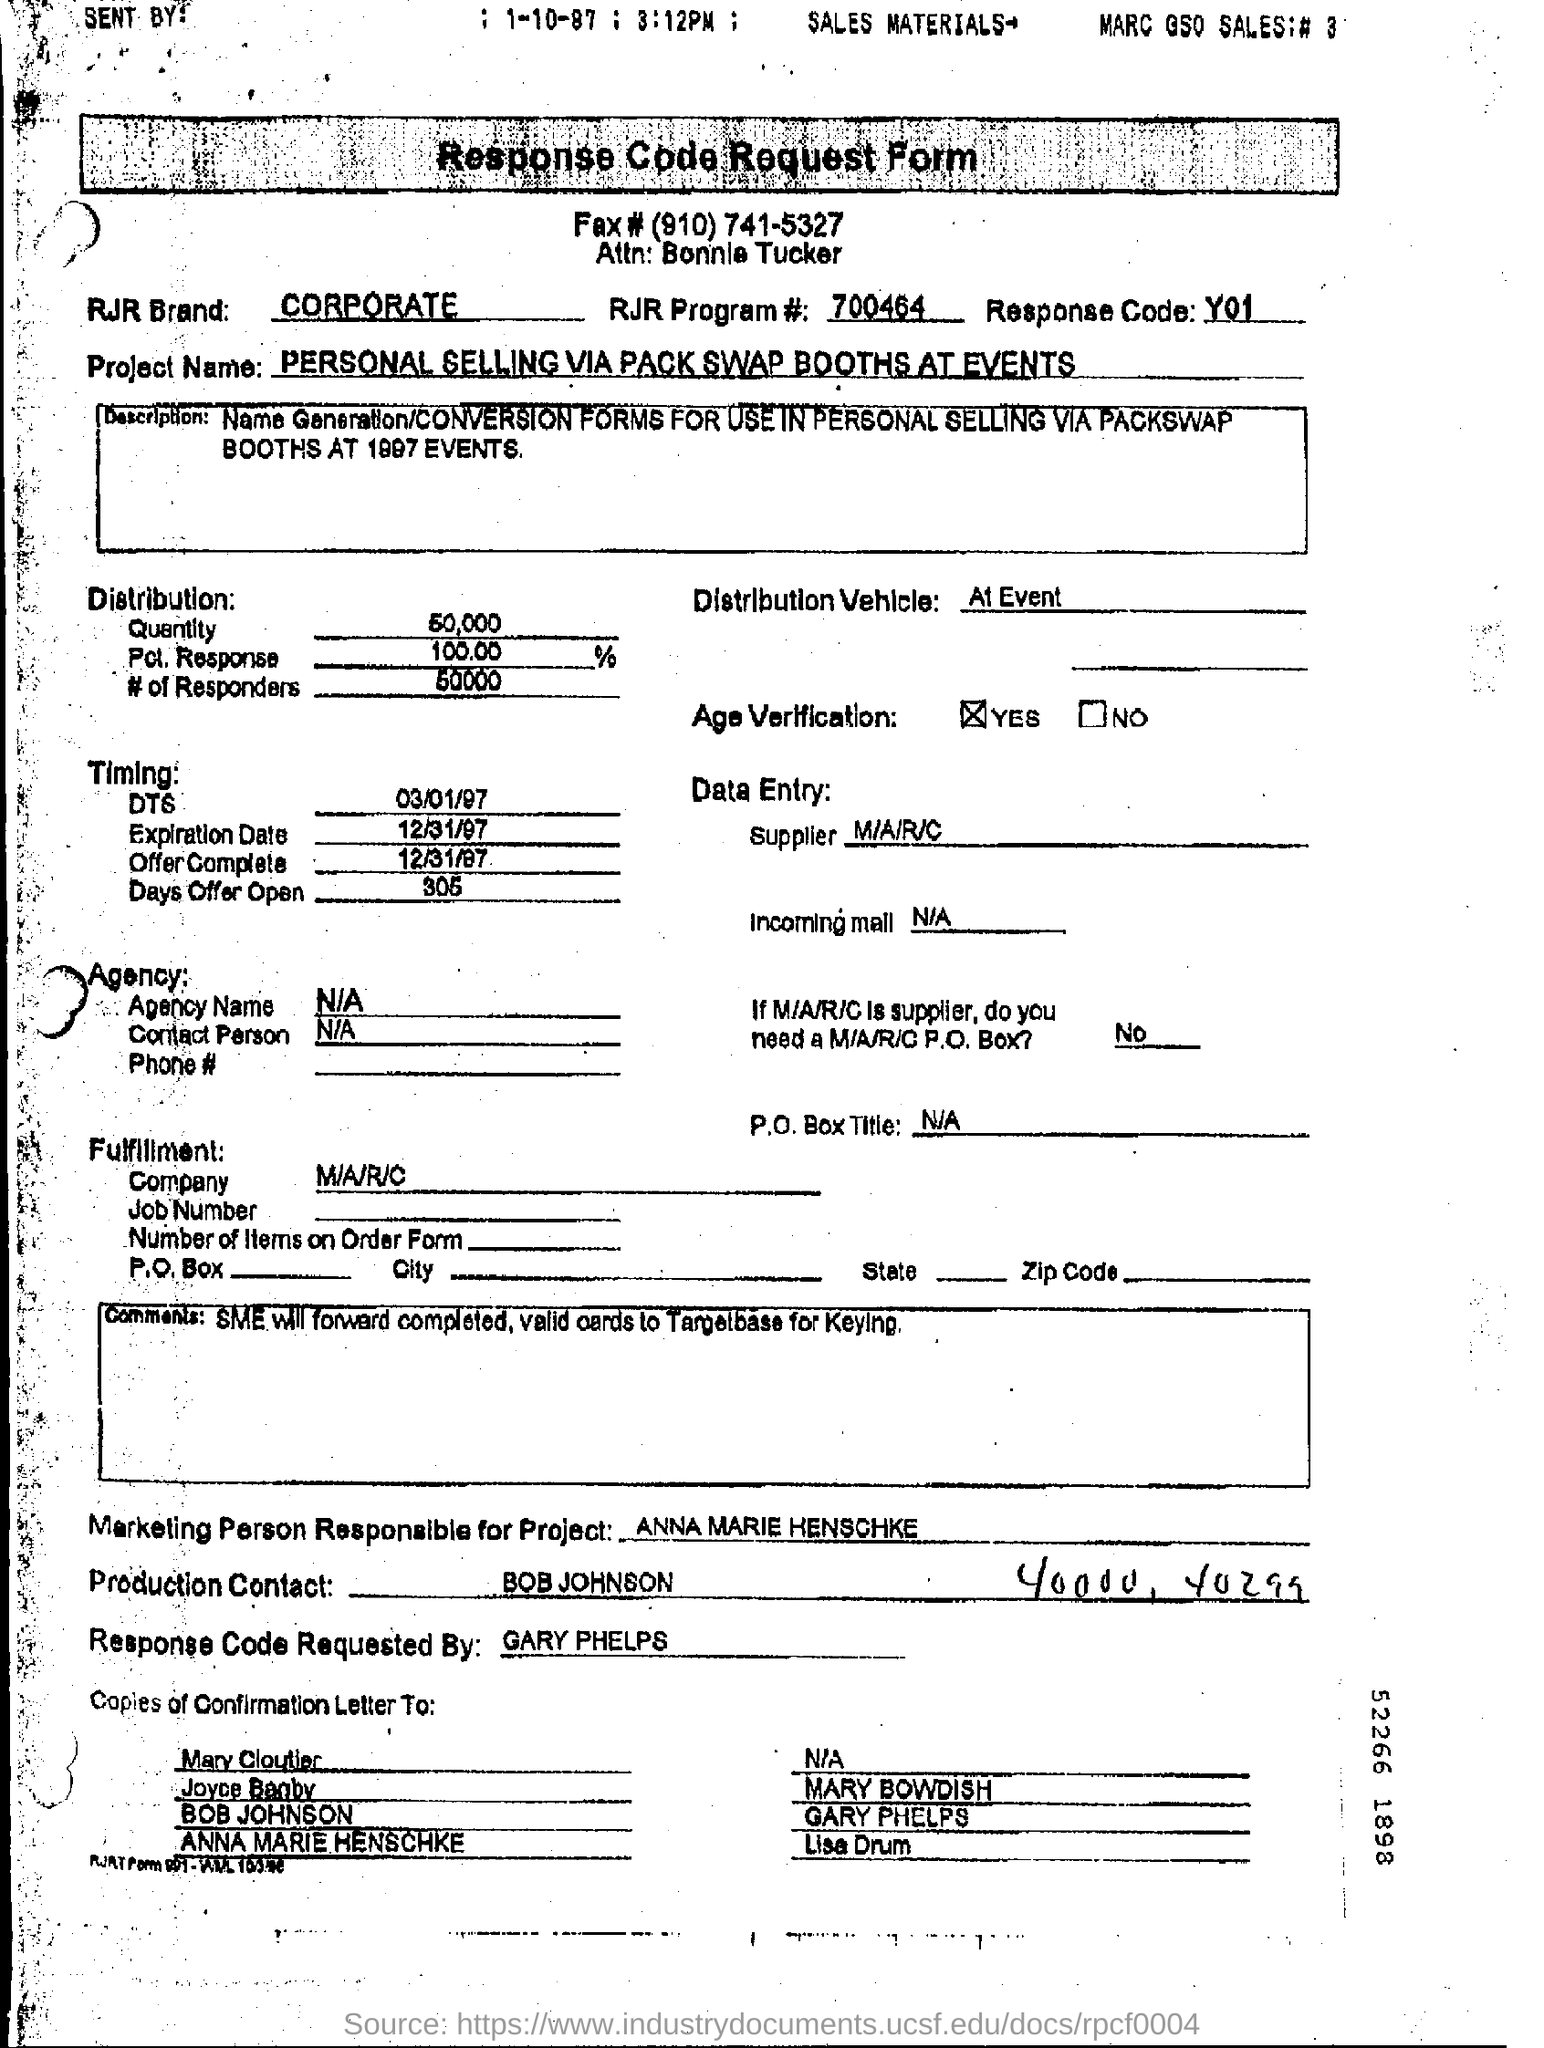What is the Project Name?
Provide a succinct answer. PERSONAL SELLING VIA PACK SWAP BOOTHS AT EVENTS. Who is the Marketing Person Responsible for Project?
Your answer should be very brief. Anna marie henschke. Who is the Production Contact?
Your answer should be very brief. Bob johnson. 